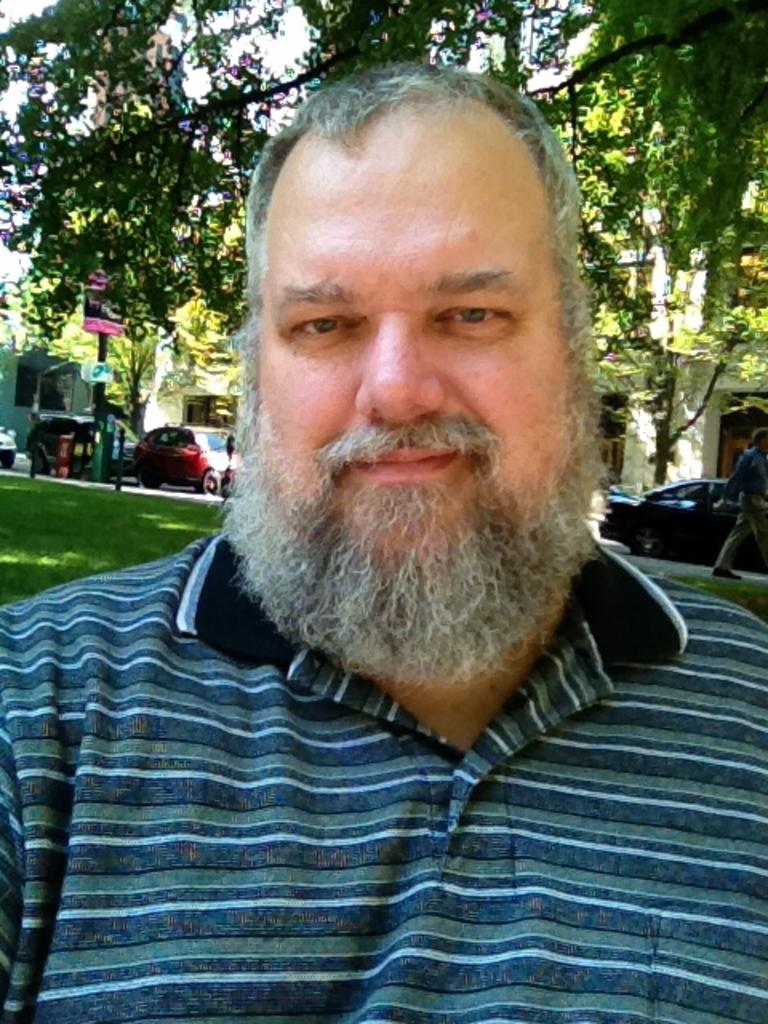Who is the main subject in the image? There is a man in the middle of the picture. What is the man wearing in the image? The man is wearing a T-shirt. What can be seen in the background of the image? There are cars and trees visible in the background of the image. How many pies are on the mountain in the image? There is no mountain or pies present in the image. What type of key is being used to unlock the door in the image? There is no door or key present in the image. 